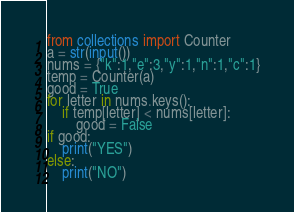Convert code to text. <code><loc_0><loc_0><loc_500><loc_500><_Python_>from collections import Counter
a = str(input())
nums = {"k":1,"e":3,"y":1,"n":1,"c":1}
temp = Counter(a)
good = True
for letter in nums.keys():
    if temp[letter] < nums[letter]:
        good = False
if good:
    print("YES")
else:
    print("NO")</code> 